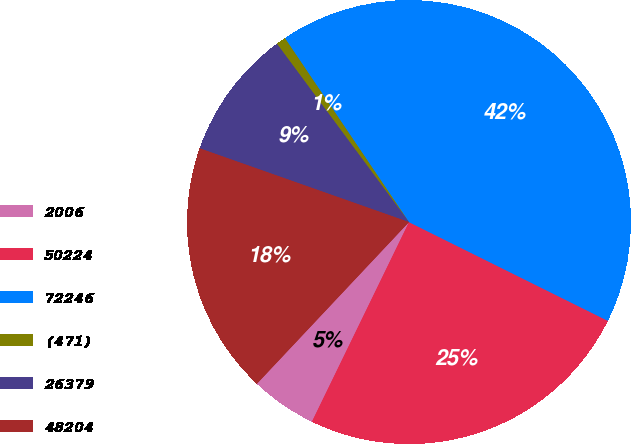Convert chart. <chart><loc_0><loc_0><loc_500><loc_500><pie_chart><fcel>2006<fcel>50224<fcel>72246<fcel>(471)<fcel>26379<fcel>48204<nl><fcel>4.81%<fcel>24.87%<fcel>41.78%<fcel>0.7%<fcel>9.46%<fcel>18.38%<nl></chart> 